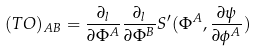<formula> <loc_0><loc_0><loc_500><loc_500>( T { \sl O } ) _ { A B } = { \frac { \partial _ { l } } { \partial \Phi ^ { A } } } { \frac { \partial _ { l } } { \partial \Phi ^ { B } } } S ^ { \prime } ( \Phi ^ { A } , { \frac { \partial \psi } { \partial \phi ^ { A } } } )</formula> 